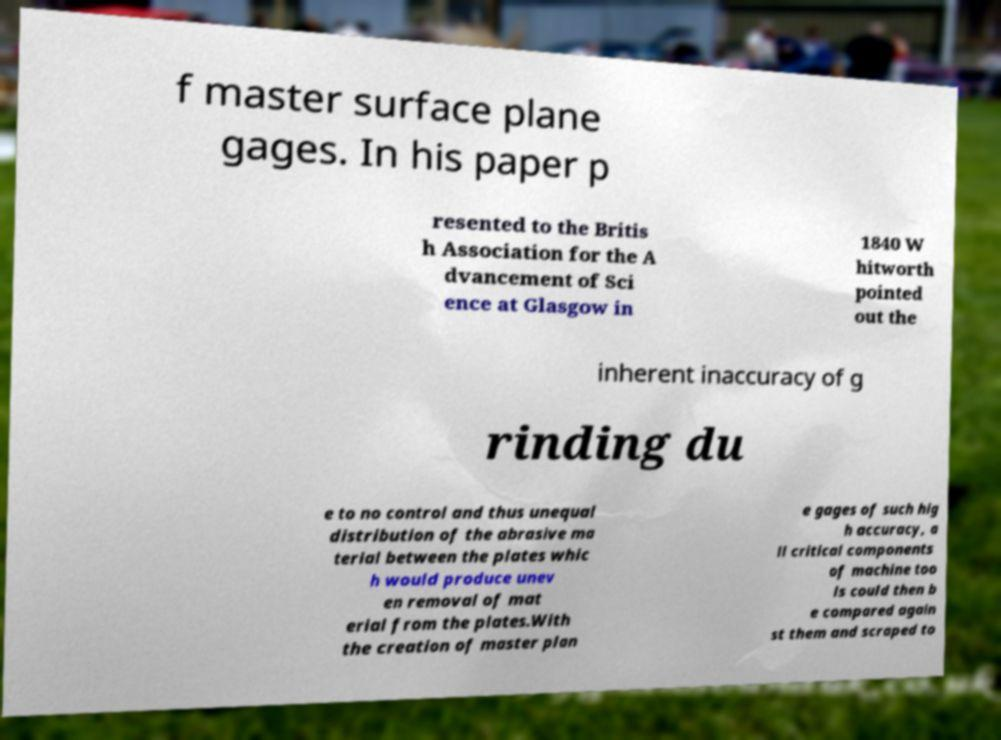Could you extract and type out the text from this image? f master surface plane gages. In his paper p resented to the Britis h Association for the A dvancement of Sci ence at Glasgow in 1840 W hitworth pointed out the inherent inaccuracy of g rinding du e to no control and thus unequal distribution of the abrasive ma terial between the plates whic h would produce unev en removal of mat erial from the plates.With the creation of master plan e gages of such hig h accuracy, a ll critical components of machine too ls could then b e compared again st them and scraped to 